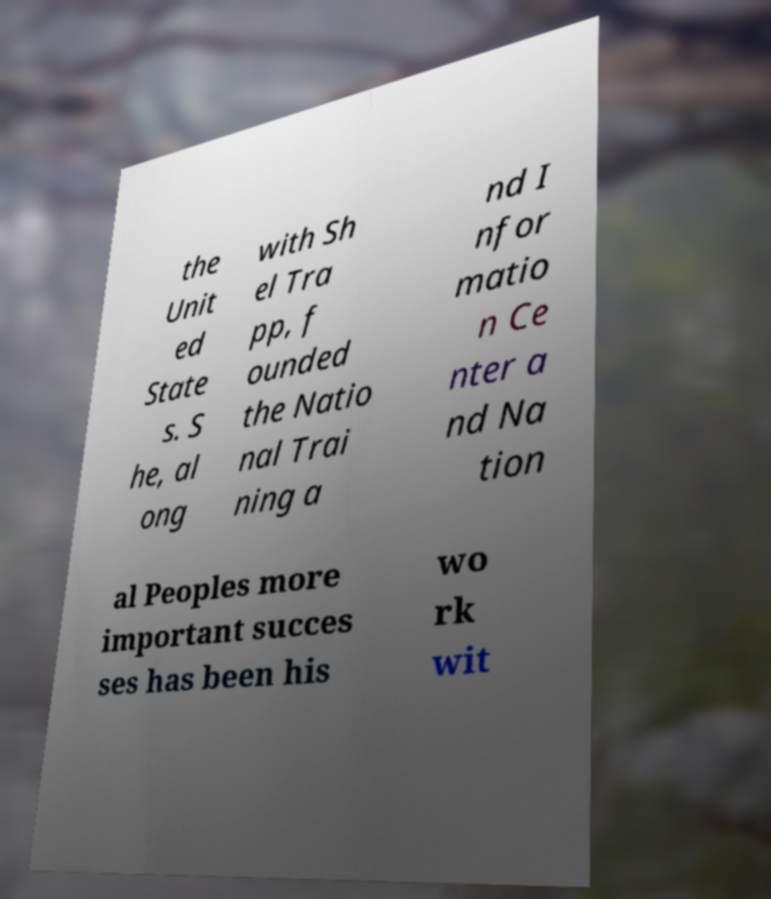Please identify and transcribe the text found in this image. the Unit ed State s. S he, al ong with Sh el Tra pp, f ounded the Natio nal Trai ning a nd I nfor matio n Ce nter a nd Na tion al Peoples more important succes ses has been his wo rk wit 